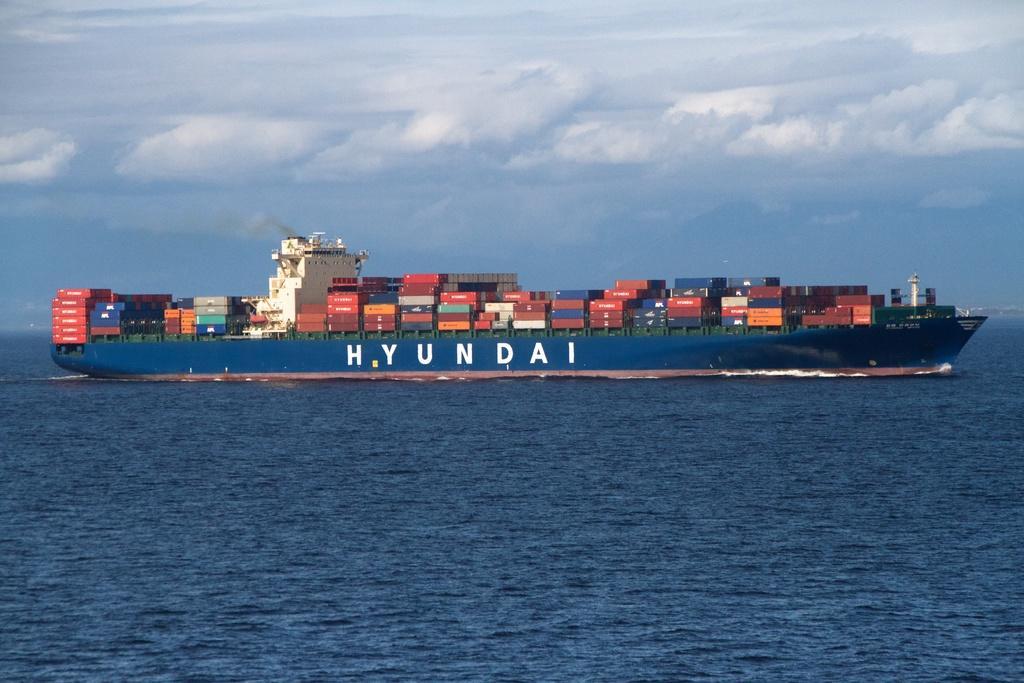In one or two sentences, can you explain what this image depicts? In the center of the image we can see containers on ship sailing on the river. In the background we can see sky and clouds. 